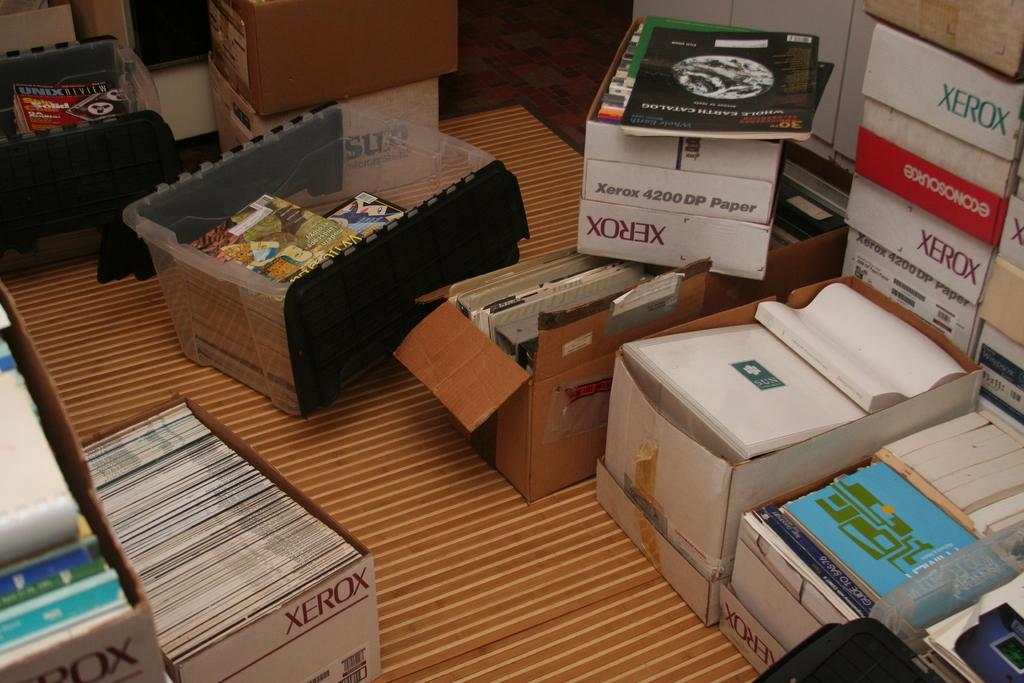<image>
Present a compact description of the photo's key features. Several xerox boxes on top of a rug are packed with books. 